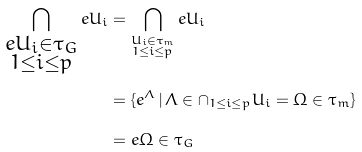<formula> <loc_0><loc_0><loc_500><loc_500>\bigcap _ { \substack { e U _ { i } \in \tau _ { G } \\ 1 \leq i \leq p } } e U _ { i } & = \bigcap _ { \substack { U _ { i } \in \tau _ { m } \\ 1 \leq i \leq p } } e U _ { i } \\ & = \{ e ^ { \Lambda } \, | \, \Lambda \in \cap _ { 1 \leq i \leq p } U _ { i } = \Omega \in \tau _ { m } \} \\ & = e \Omega \in \tau _ { G }</formula> 